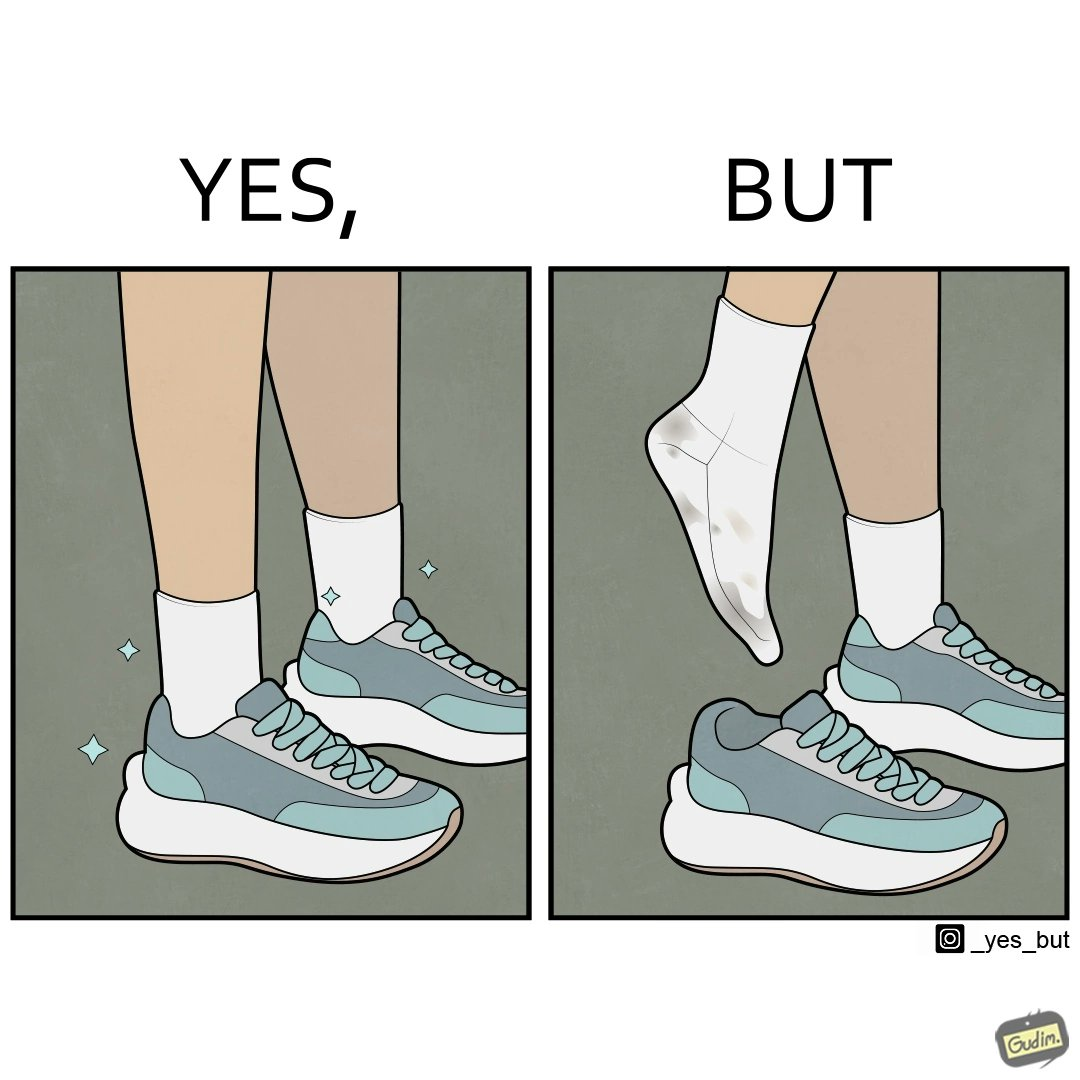Would you classify this image as satirical? Yes, this image is satirical. 